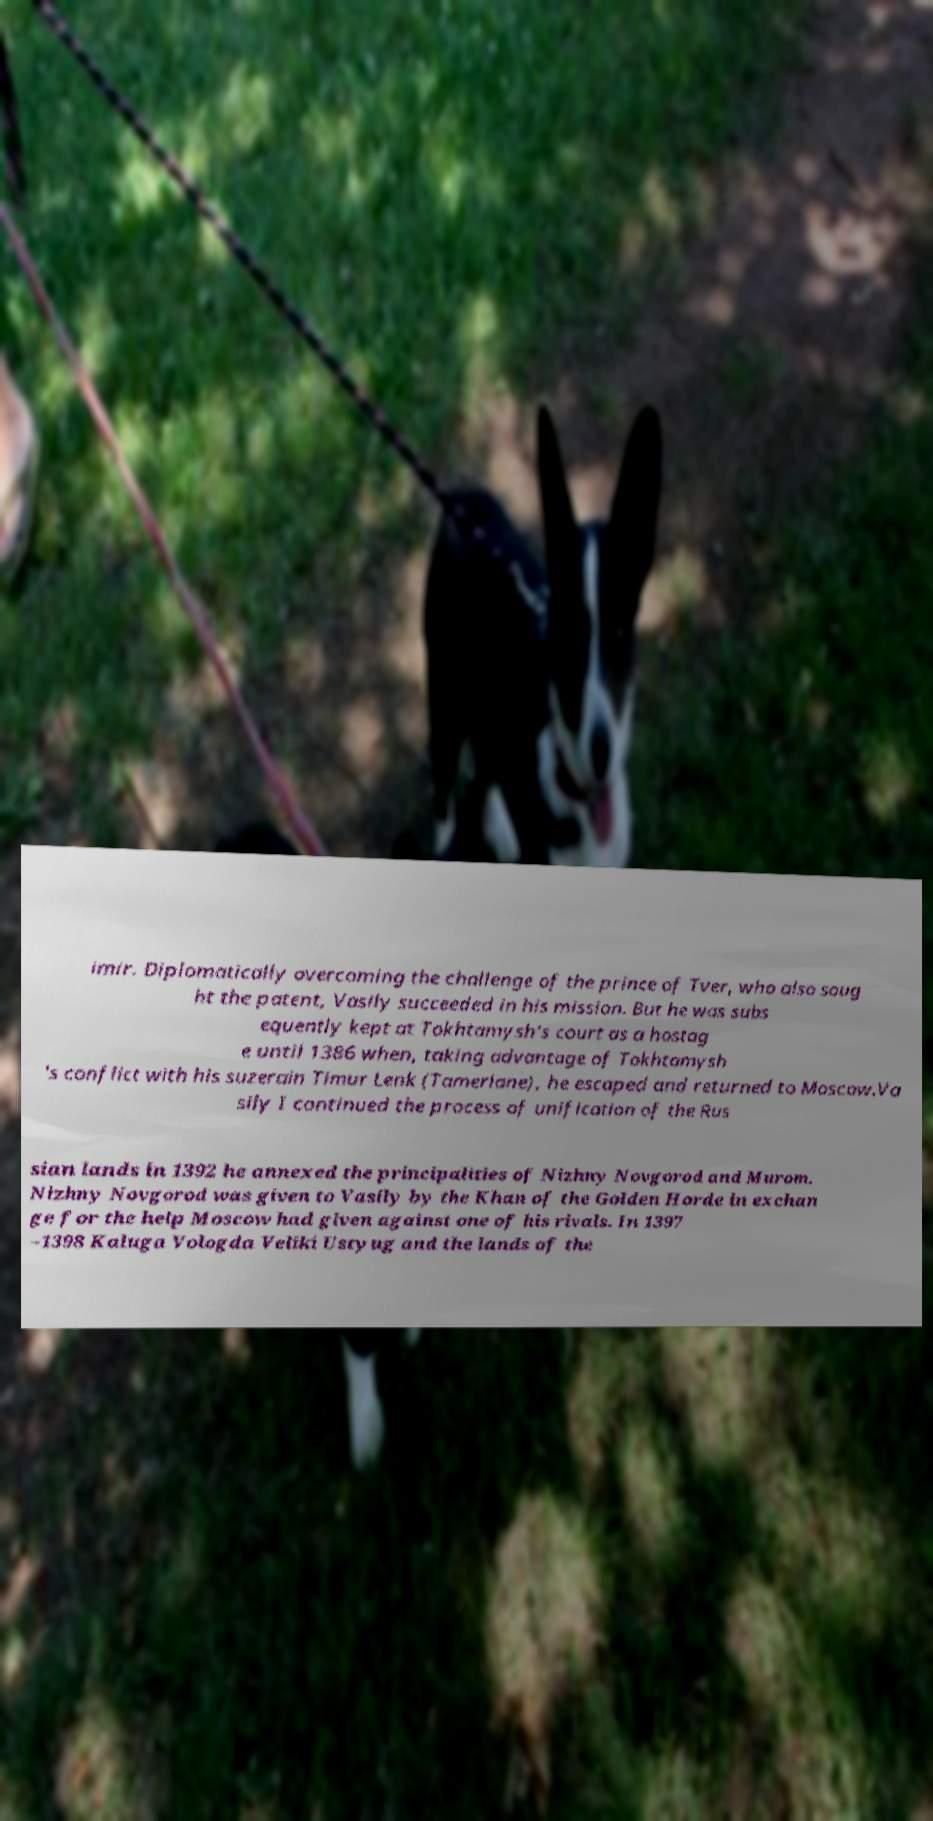For documentation purposes, I need the text within this image transcribed. Could you provide that? imir. Diplomatically overcoming the challenge of the prince of Tver, who also soug ht the patent, Vasily succeeded in his mission. But he was subs equently kept at Tokhtamysh's court as a hostag e until 1386 when, taking advantage of Tokhtamysh 's conflict with his suzerain Timur Lenk (Tamerlane), he escaped and returned to Moscow.Va sily I continued the process of unification of the Rus sian lands in 1392 he annexed the principalities of Nizhny Novgorod and Murom. Nizhny Novgorod was given to Vasily by the Khan of the Golden Horde in exchan ge for the help Moscow had given against one of his rivals. In 1397 –1398 Kaluga Vologda Veliki Ustyug and the lands of the 